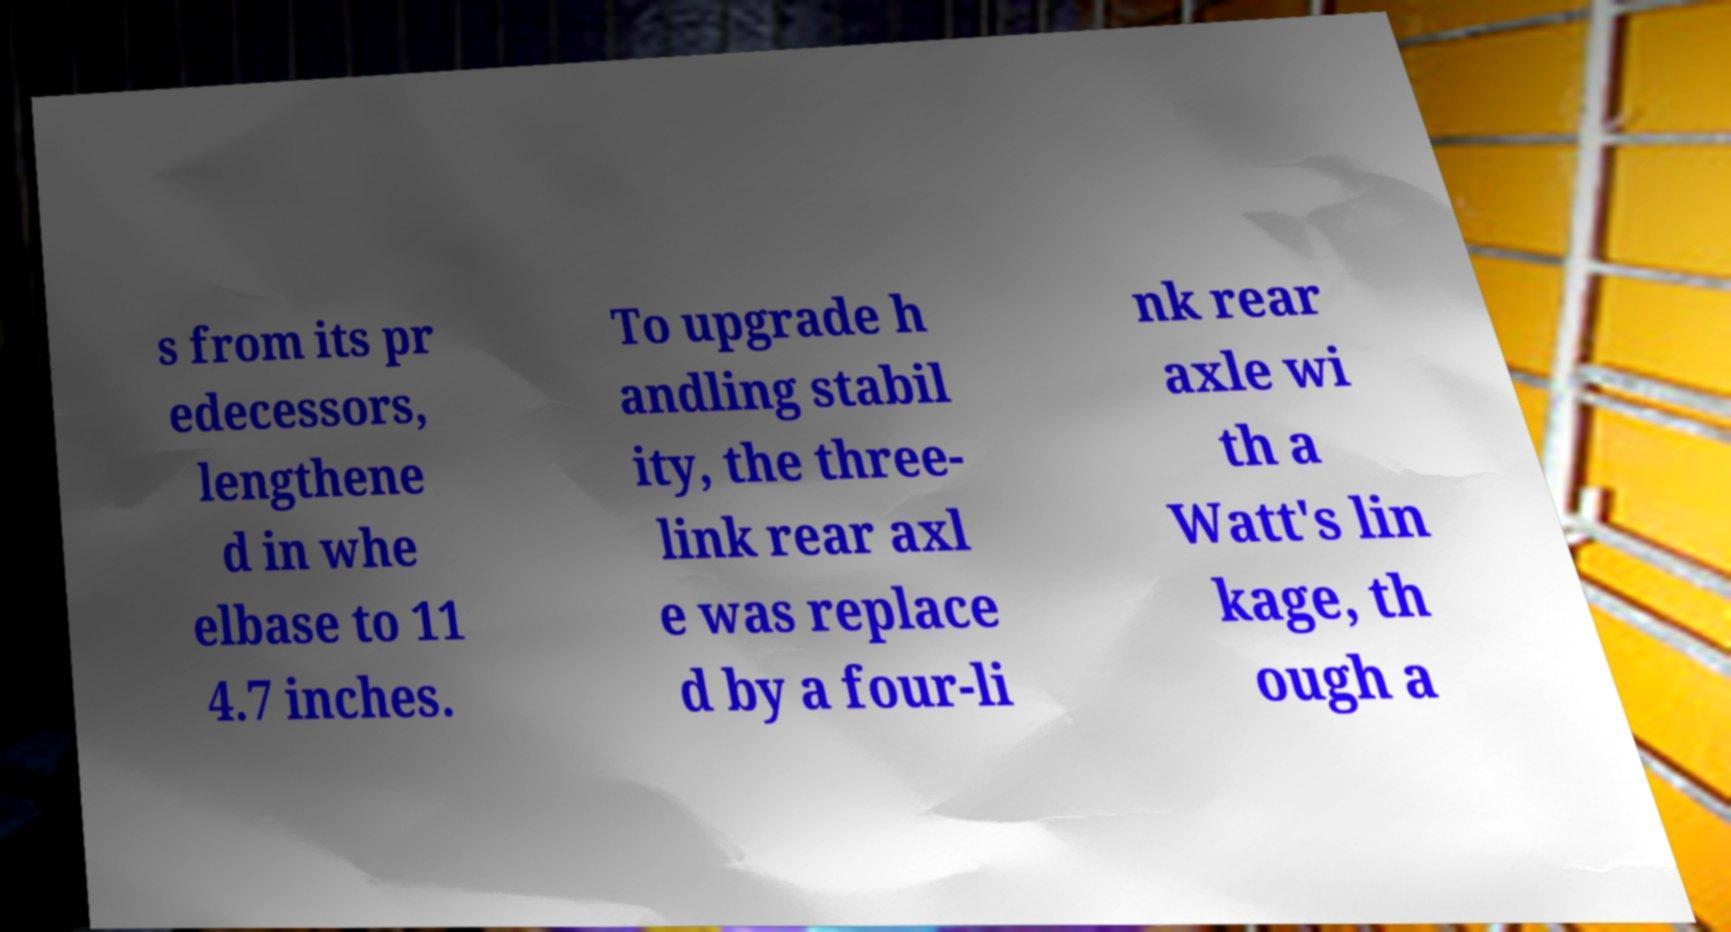Could you assist in decoding the text presented in this image and type it out clearly? s from its pr edecessors, lengthene d in whe elbase to 11 4.7 inches. To upgrade h andling stabil ity, the three- link rear axl e was replace d by a four-li nk rear axle wi th a Watt's lin kage, th ough a 